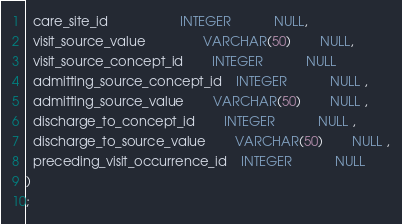<code> <loc_0><loc_0><loc_500><loc_500><_SQL_>  care_site_id					INTEGER			NULL,
  visit_source_value				VARCHAR(50)		NULL,
  visit_source_concept_id		INTEGER			NULL
  admitting_source_concept_id	INTEGER			NULL ,
  admitting_source_value		VARCHAR(50)		NULL ,
  discharge_to_concept_id		INTEGER			NULL ,
  discharge_to_source_value		VARCHAR(50)		NULL ,
  preceding_visit_occurrence_id	INTEGER			NULL
)
;</code> 